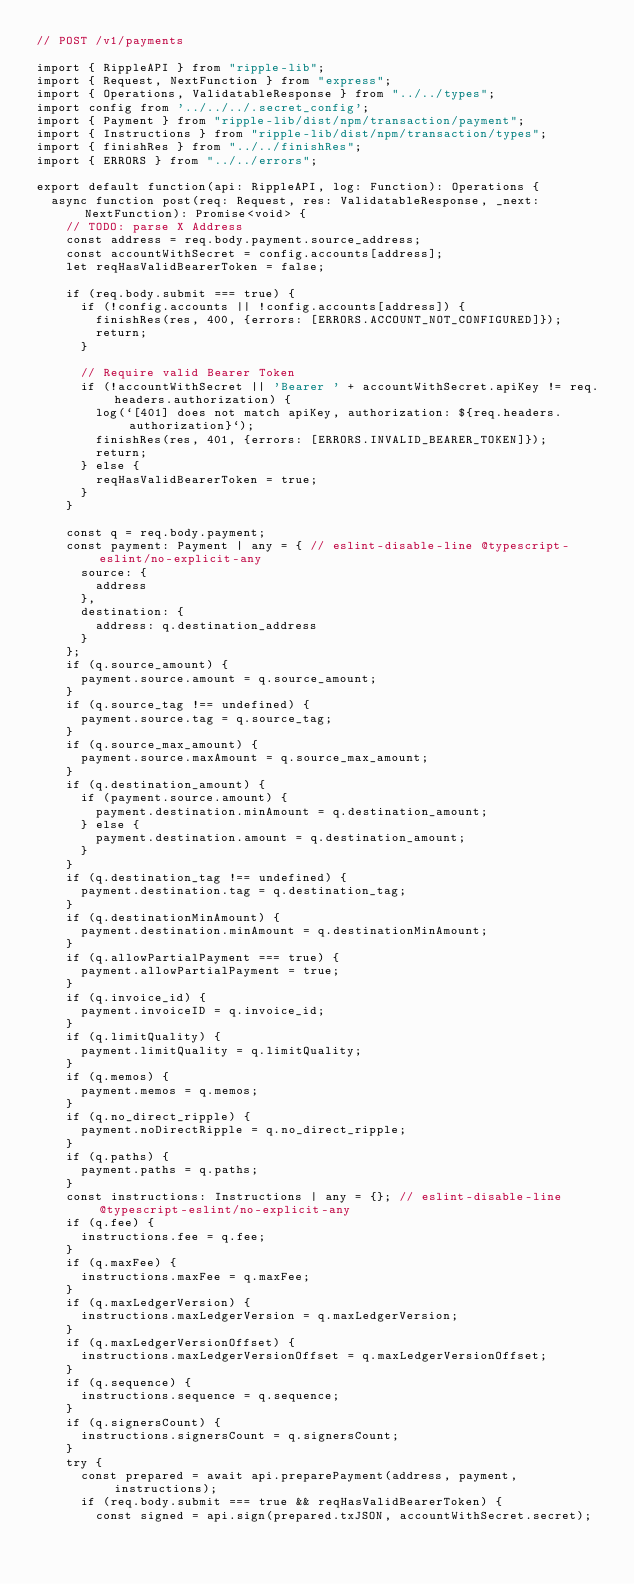Convert code to text. <code><loc_0><loc_0><loc_500><loc_500><_TypeScript_>// POST /v1/payments

import { RippleAPI } from "ripple-lib";
import { Request, NextFunction } from "express";
import { Operations, ValidatableResponse } from "../../types";
import config from '../../../.secret_config';
import { Payment } from "ripple-lib/dist/npm/transaction/payment";
import { Instructions } from "ripple-lib/dist/npm/transaction/types";
import { finishRes } from "../../finishRes";
import { ERRORS } from "../../errors";

export default function(api: RippleAPI, log: Function): Operations {
  async function post(req: Request, res: ValidatableResponse, _next: NextFunction): Promise<void> {
    // TODO: parse X Address
    const address = req.body.payment.source_address;
    const accountWithSecret = config.accounts[address];
    let reqHasValidBearerToken = false;

    if (req.body.submit === true) {
      if (!config.accounts || !config.accounts[address]) {
        finishRes(res, 400, {errors: [ERRORS.ACCOUNT_NOT_CONFIGURED]});
        return;
      }

      // Require valid Bearer Token
      if (!accountWithSecret || 'Bearer ' + accountWithSecret.apiKey != req.headers.authorization) {
        log(`[401] does not match apiKey, authorization: ${req.headers.authorization}`);
        finishRes(res, 401, {errors: [ERRORS.INVALID_BEARER_TOKEN]});
        return;
      } else {
        reqHasValidBearerToken = true;
      }
    }

    const q = req.body.payment;
    const payment: Payment | any = { // eslint-disable-line @typescript-eslint/no-explicit-any
      source: {
        address
      },
      destination: {
        address: q.destination_address
      }
    };
    if (q.source_amount) {
      payment.source.amount = q.source_amount;
    }
    if (q.source_tag !== undefined) {
      payment.source.tag = q.source_tag;
    }
    if (q.source_max_amount) {
      payment.source.maxAmount = q.source_max_amount;
    }
    if (q.destination_amount) {
      if (payment.source.amount) {
        payment.destination.minAmount = q.destination_amount;
      } else {
        payment.destination.amount = q.destination_amount;
      }
    }
    if (q.destination_tag !== undefined) {
      payment.destination.tag = q.destination_tag;
    }
    if (q.destinationMinAmount) {
      payment.destination.minAmount = q.destinationMinAmount;
    }
    if (q.allowPartialPayment === true) {
      payment.allowPartialPayment = true;
    }
    if (q.invoice_id) {
      payment.invoiceID = q.invoice_id;
    }
    if (q.limitQuality) {
      payment.limitQuality = q.limitQuality;
    }
    if (q.memos) {
      payment.memos = q.memos;
    }
    if (q.no_direct_ripple) {
      payment.noDirectRipple = q.no_direct_ripple;
    }
    if (q.paths) {
      payment.paths = q.paths;
    }
    const instructions: Instructions | any = {}; // eslint-disable-line @typescript-eslint/no-explicit-any
    if (q.fee) {
      instructions.fee = q.fee;
    }
    if (q.maxFee) {
      instructions.maxFee = q.maxFee;
    }
    if (q.maxLedgerVersion) {
      instructions.maxLedgerVersion = q.maxLedgerVersion;
    }
    if (q.maxLedgerVersionOffset) {
      instructions.maxLedgerVersionOffset = q.maxLedgerVersionOffset;
    }
    if (q.sequence) {
      instructions.sequence = q.sequence;
    }
    if (q.signersCount) {
      instructions.signersCount = q.signersCount;
    }
    try {
      const prepared = await api.preparePayment(address, payment, instructions);
      if (req.body.submit === true && reqHasValidBearerToken) {
        const signed = api.sign(prepared.txJSON, accountWithSecret.secret);</code> 